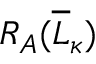Convert formula to latex. <formula><loc_0><loc_0><loc_500><loc_500>R _ { A } ( \overline { L } _ { \kappa } )</formula> 